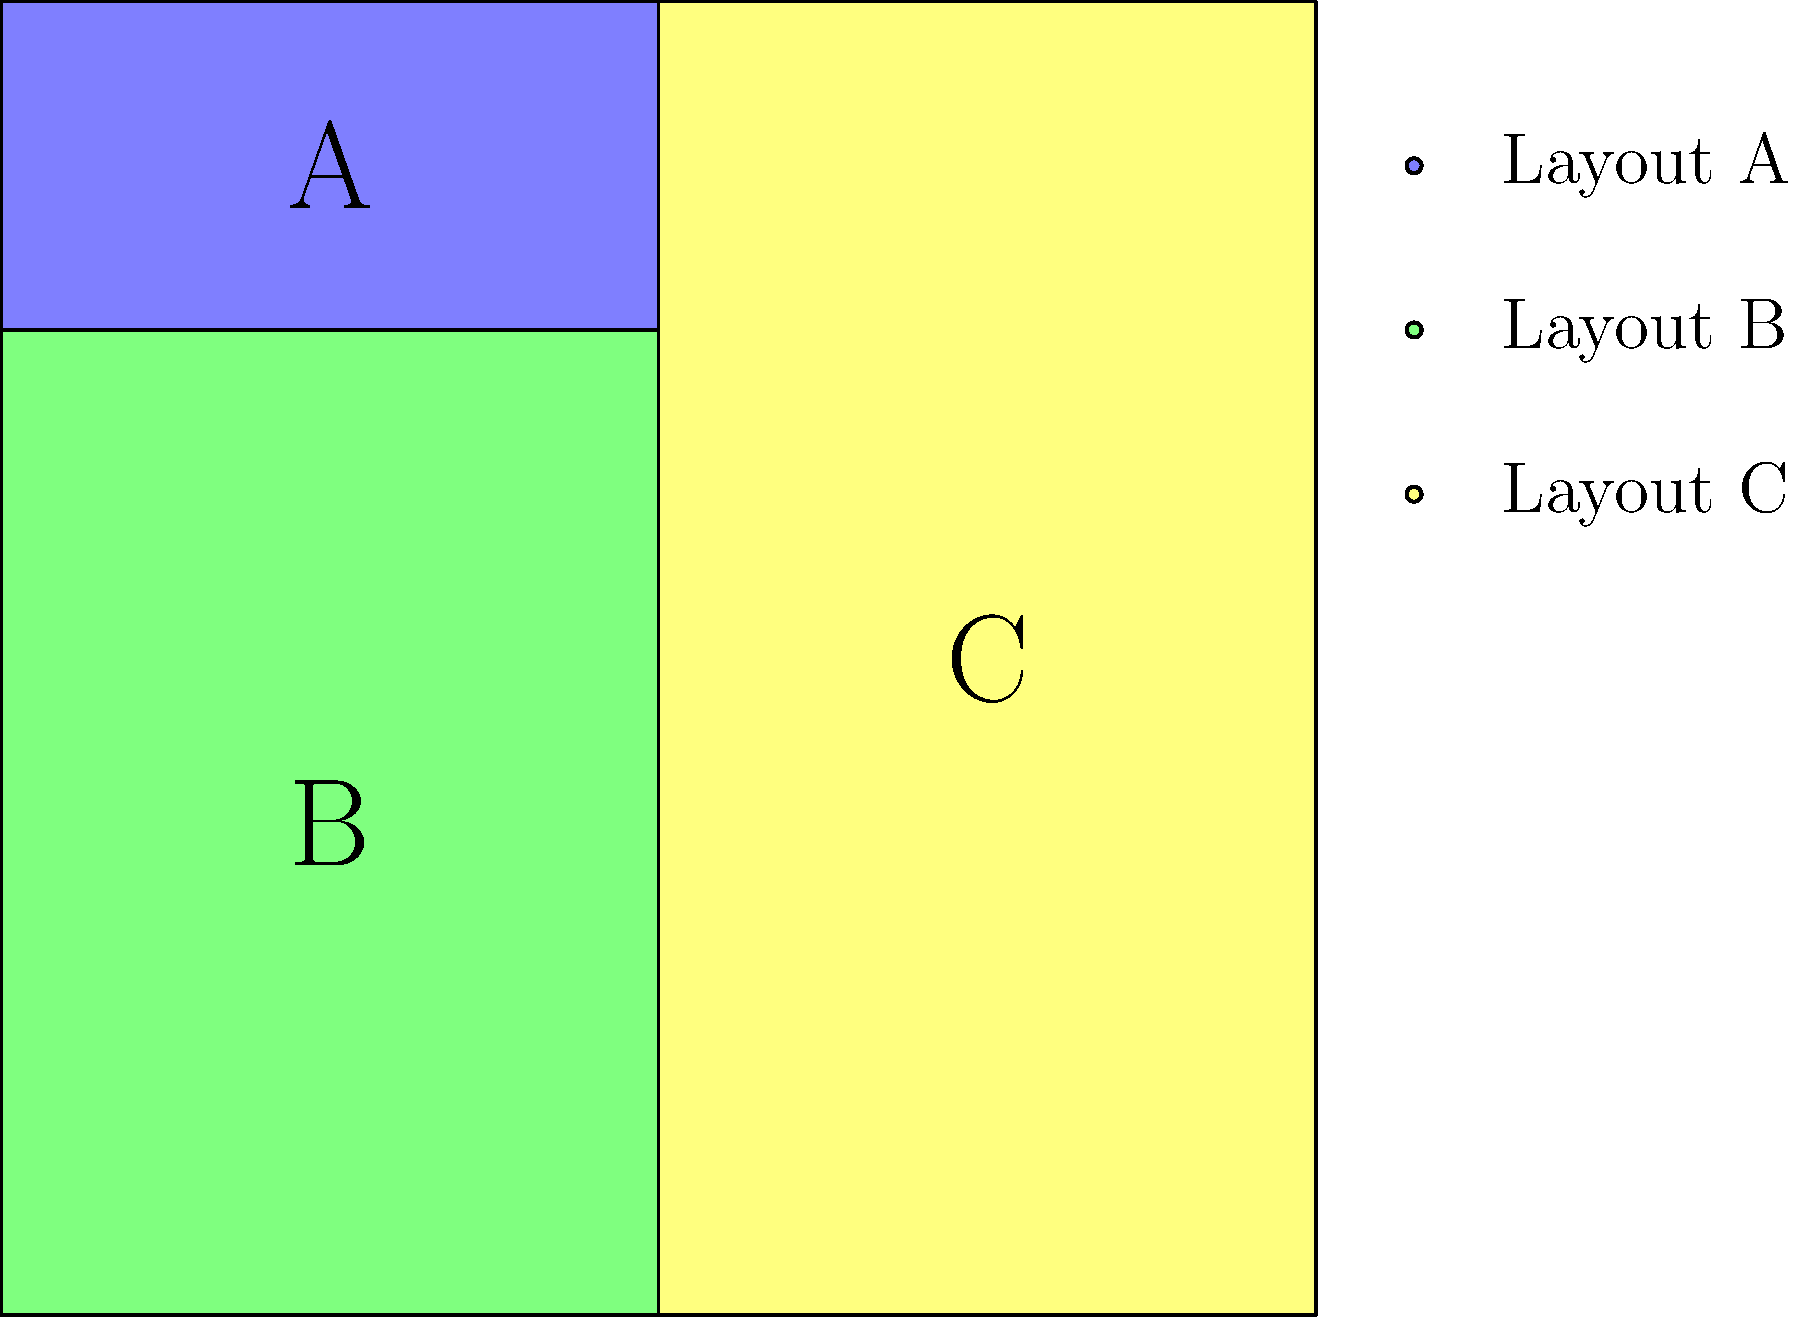As a UX designer, you are tasked with evaluating different layouts for a responsive web design. The mockup above shows three content areas (A, B, and C) arranged in Layout A. Which of the following statements best describes the most suitable responsive behavior for this layout on smaller screens? To determine the most suitable responsive behavior for Layout A on smaller screens, let's analyze the layout and consider UX best practices:

1. Current layout analysis:
   - Area A: Spans the top of the layout, likely a header or important content.
   - Area B: Takes up the left side, possibly main content or navigation.
   - Area C: Occupies the right side, could be secondary content or sidebar.

2. Responsive design principles:
   - Content should reflow to fit smaller screens.
   - Most important content should appear first.
   - Maintain a logical reading order.

3. Considerations for smaller screens:
   - Vertical scrolling is more natural than horizontal on mobile devices.
   - Single-column layouts are often more suitable for narrow screens.

4. Proposed responsive behavior:
   - Area A should remain at the top due to its likely importance.
   - Areas B and C should stack vertically below A.
   - The order should be A, then B, then C to maintain content hierarchy.

5. User-centered approach:
   - This arrangement ensures the most critical information (A) is seen first.
   - It allows for easy vertical scrolling to access all content.
   - It maintains a clear visual hierarchy and logical flow of information.

Therefore, the most suitable responsive behavior would be to stack the content areas vertically in the order A, B, C when viewed on smaller screens.
Answer: Stack vertically: A, B, C 